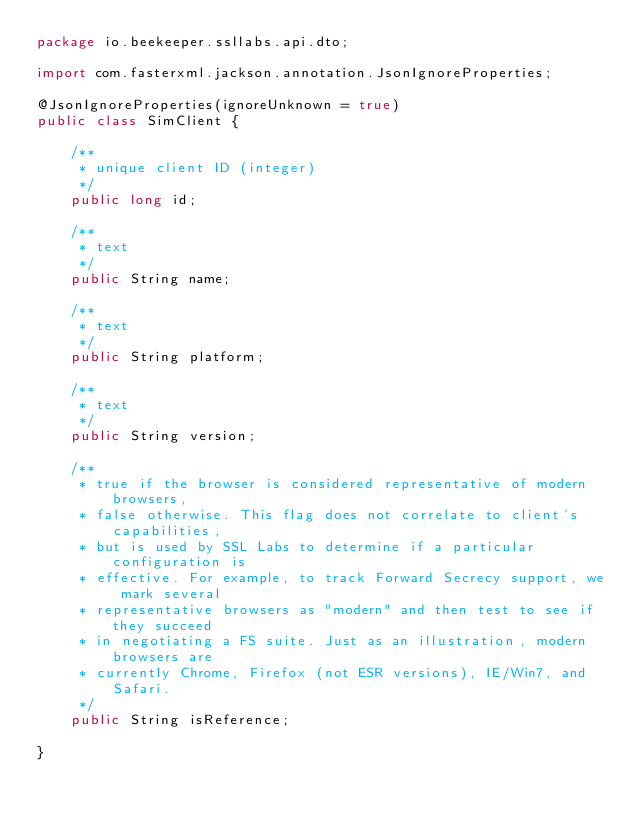Convert code to text. <code><loc_0><loc_0><loc_500><loc_500><_Java_>package io.beekeeper.ssllabs.api.dto;

import com.fasterxml.jackson.annotation.JsonIgnoreProperties;

@JsonIgnoreProperties(ignoreUnknown = true)
public class SimClient {

    /**
     * unique client ID (integer)
     */
    public long id;

    /**
     * text
     */
    public String name;

    /**
     * text
     */
    public String platform;

    /**
     * text
     */
    public String version;

    /**
     * true if the browser is considered representative of modern browsers,
     * false otherwise. This flag does not correlate to client's capabilities,
     * but is used by SSL Labs to determine if a particular configuration is
     * effective. For example, to track Forward Secrecy support, we mark several
     * representative browsers as "modern" and then test to see if they succeed
     * in negotiating a FS suite. Just as an illustration, modern browsers are
     * currently Chrome, Firefox (not ESR versions), IE/Win7, and Safari.
     */
    public String isReference;

}
</code> 